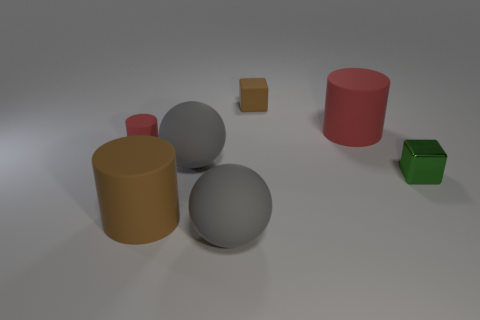Subtract all cyan balls. Subtract all gray blocks. How many balls are left? 2 Add 2 metal things. How many objects exist? 9 Subtract all cylinders. How many objects are left? 4 Add 5 large gray rubber cylinders. How many large gray rubber cylinders exist? 5 Subtract 0 green balls. How many objects are left? 7 Subtract all large brown cylinders. Subtract all tiny green cubes. How many objects are left? 5 Add 1 big brown matte cylinders. How many big brown matte cylinders are left? 2 